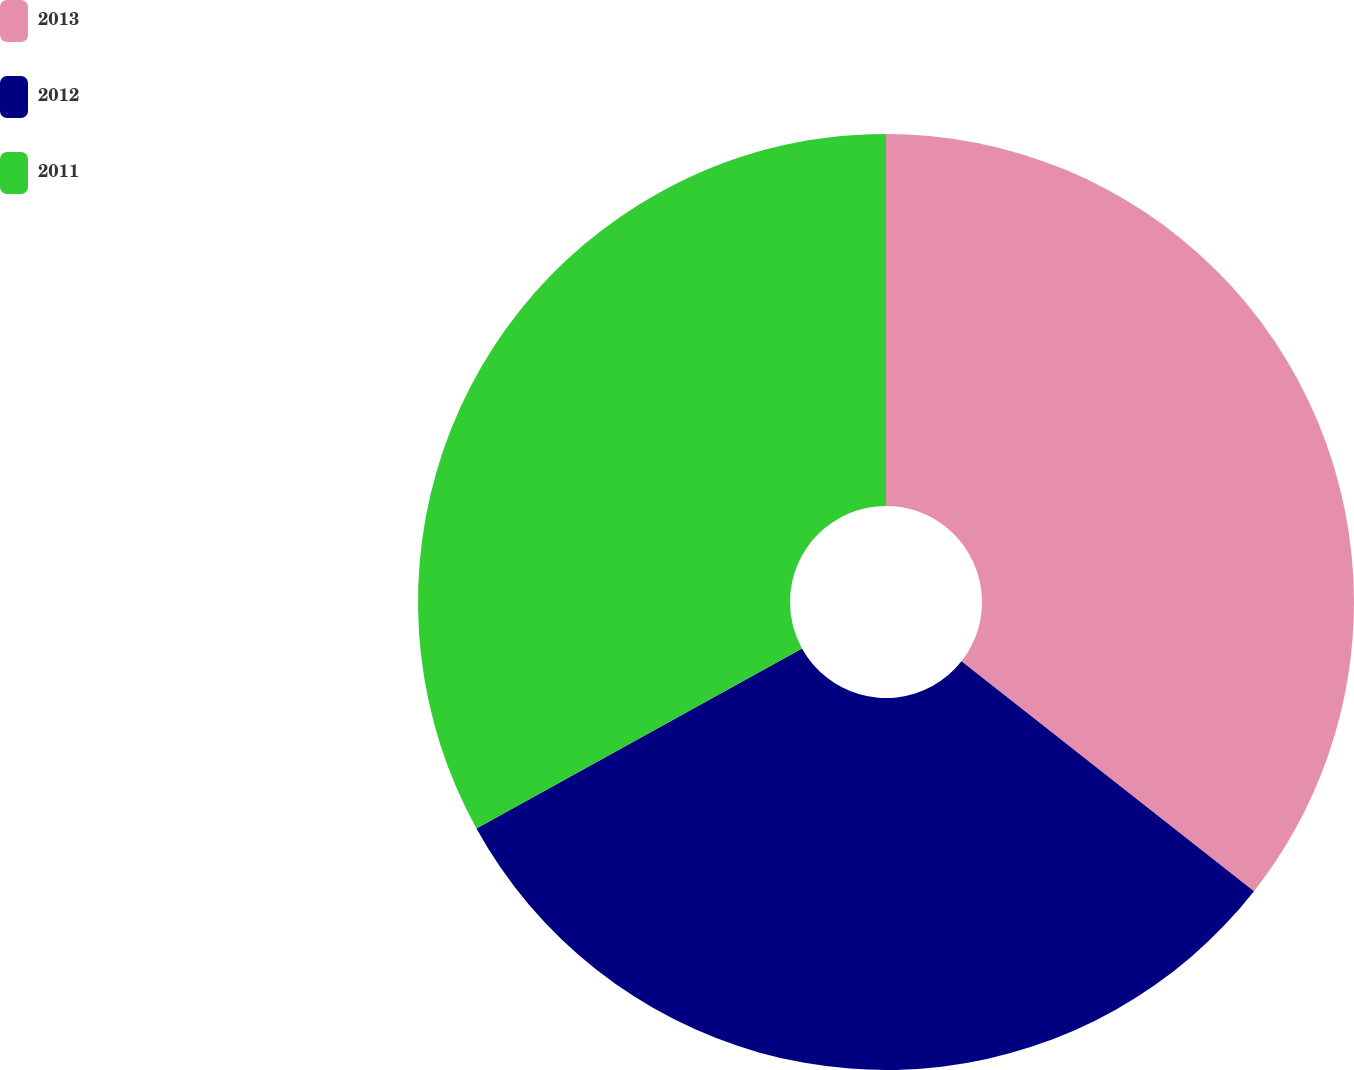<chart> <loc_0><loc_0><loc_500><loc_500><pie_chart><fcel>2013<fcel>2012<fcel>2011<nl><fcel>35.6%<fcel>31.36%<fcel>33.04%<nl></chart> 